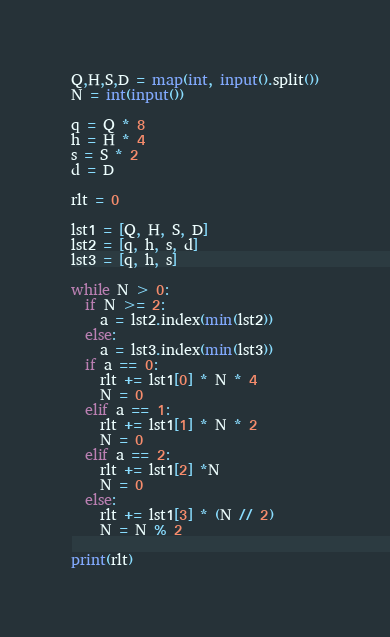Convert code to text. <code><loc_0><loc_0><loc_500><loc_500><_Python_>Q,H,S,D = map(int, input().split())
N = int(input())

q = Q * 8
h = H * 4
s = S * 2
d = D

rlt = 0

lst1 = [Q, H, S, D]
lst2 = [q, h, s, d]
lst3 = [q, h, s]

while N > 0:
  if N >= 2:
    a = lst2.index(min(lst2))
  else:
    a = lst3.index(min(lst3))
  if a == 0:
    rlt += lst1[0] * N * 4
    N = 0
  elif a == 1:
    rlt += lst1[1] * N * 2
    N = 0
  elif a == 2:
    rlt += lst1[2] *N
    N = 0
  else:
    rlt += lst1[3] * (N // 2)
    N = N % 2

print(rlt)
</code> 